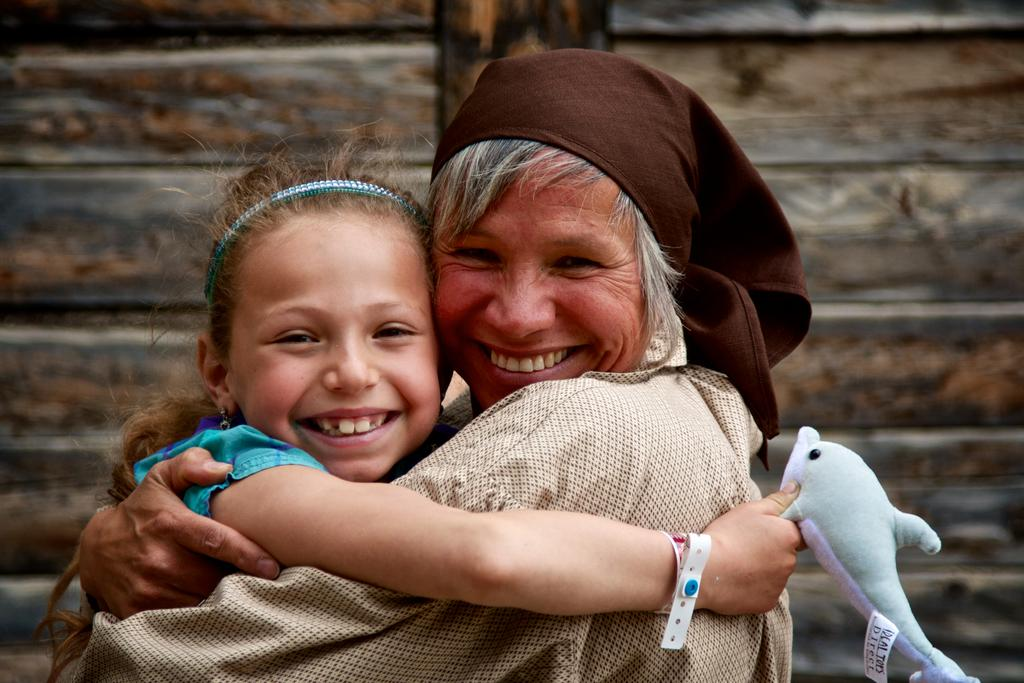How many people are in the image? There are two people in the image. What is the facial expression of the people in the image? Both people are smiling. What are the people wearing in the image? The people are wearing different color dresses. What object is one of the people holding in the image? One person is holding a fish toy. What colors can be seen in the background of the image? The background has brown and black colors. Can you tell me how many times the dad breathes in the image? There is no dad present in the image, and therefore we cannot determine how many times they breathe. What type of stone is visible in the image? There is no stone present in the image. 